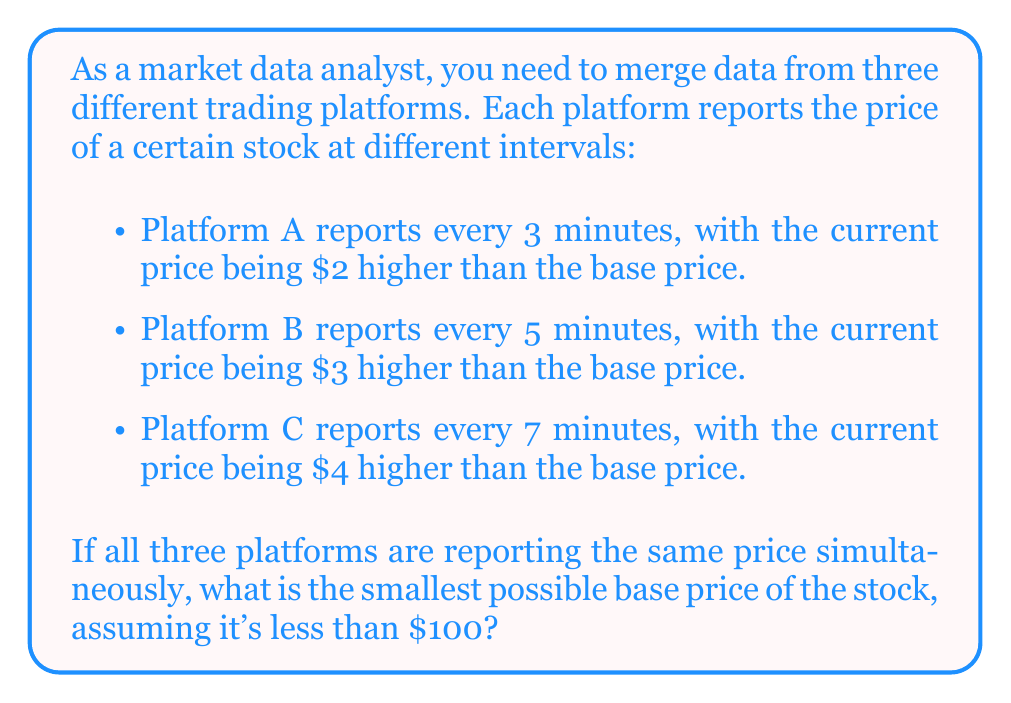Can you answer this question? Let's approach this problem using the Chinese Remainder Theorem (CRT):

1) First, we set up the system of linear congruences:
   $x \equiv 2 \pmod{3}$
   $x \equiv 3 \pmod{5}$
   $x \equiv 4 \pmod{7}$

2) Calculate $N = 3 \times 5 \times 7 = 105$

3) Calculate $N_i$ for each congruence:
   $N_1 = 105 / 3 = 35$
   $N_2 = 105 / 5 = 21$
   $N_3 = 105 / 7 = 15$

4) Find the modular multiplicative inverses:
   $35^{-1} \equiv 2 \pmod{3}$
   $21^{-1} \equiv 1 \pmod{5}$
   $15^{-1} \equiv 1 \pmod{7}$

5) Calculate the solution:
   $x = (2 \times 35 \times 2 + 3 \times 21 \times 1 + 4 \times 15 \times 1) \pmod{105}$
   $x = (140 + 63 + 60) \pmod{105}$
   $x = 263 \pmod{105}$
   $x = 53$

6) Verify the solution:
   $53 \equiv 2 \pmod{3}$
   $53 \equiv 3 \pmod{5}$
   $53 \equiv 4 \pmod{7}$

Therefore, the smallest possible base price of the stock is $53.
Answer: $53 